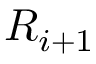Convert formula to latex. <formula><loc_0><loc_0><loc_500><loc_500>R _ { i + 1 }</formula> 